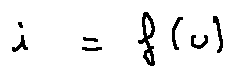<formula> <loc_0><loc_0><loc_500><loc_500>i = f ( u )</formula> 